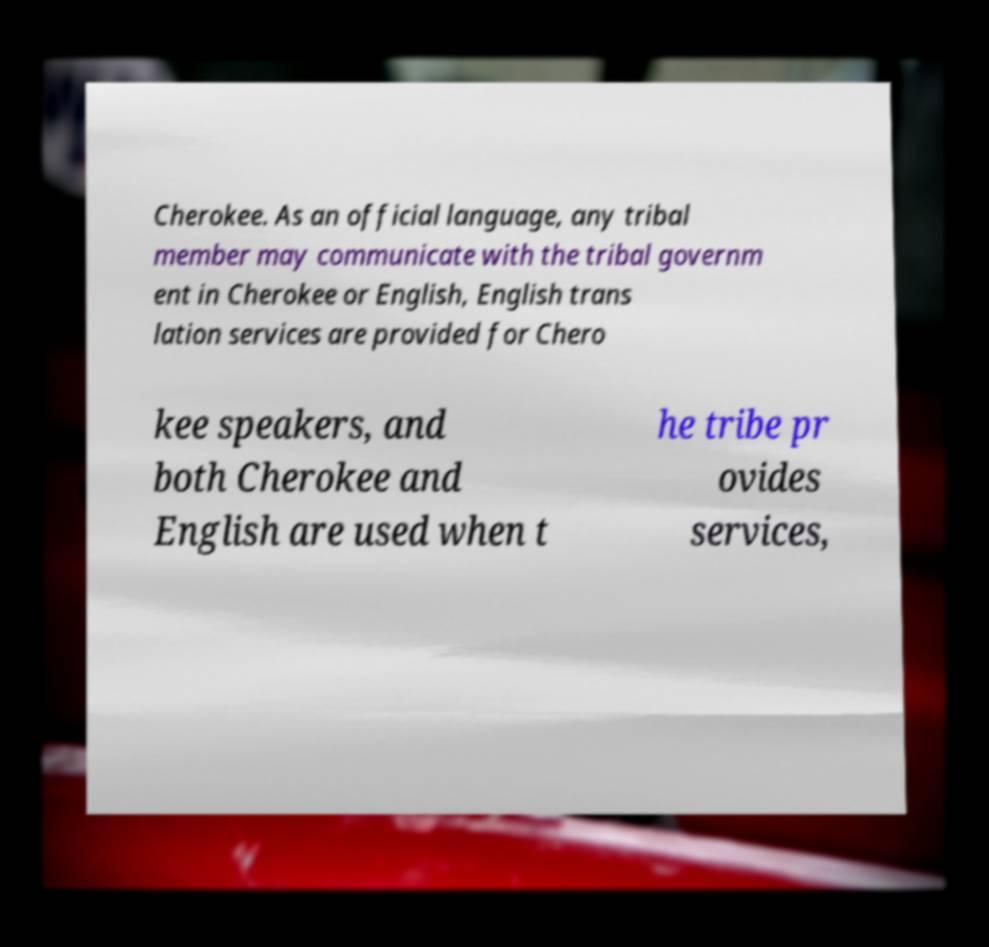There's text embedded in this image that I need extracted. Can you transcribe it verbatim? Cherokee. As an official language, any tribal member may communicate with the tribal governm ent in Cherokee or English, English trans lation services are provided for Chero kee speakers, and both Cherokee and English are used when t he tribe pr ovides services, 